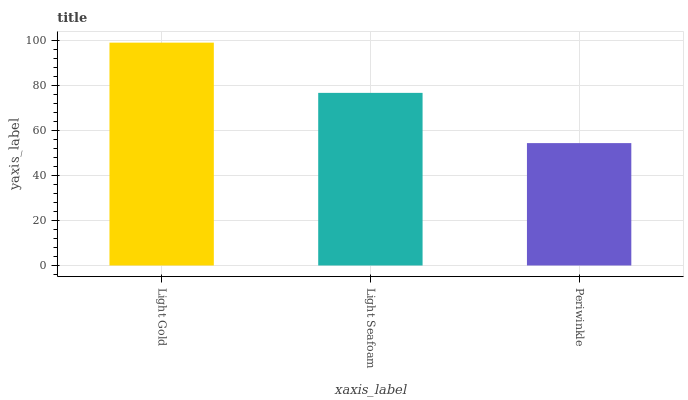Is Periwinkle the minimum?
Answer yes or no. Yes. Is Light Gold the maximum?
Answer yes or no. Yes. Is Light Seafoam the minimum?
Answer yes or no. No. Is Light Seafoam the maximum?
Answer yes or no. No. Is Light Gold greater than Light Seafoam?
Answer yes or no. Yes. Is Light Seafoam less than Light Gold?
Answer yes or no. Yes. Is Light Seafoam greater than Light Gold?
Answer yes or no. No. Is Light Gold less than Light Seafoam?
Answer yes or no. No. Is Light Seafoam the high median?
Answer yes or no. Yes. Is Light Seafoam the low median?
Answer yes or no. Yes. Is Periwinkle the high median?
Answer yes or no. No. Is Periwinkle the low median?
Answer yes or no. No. 